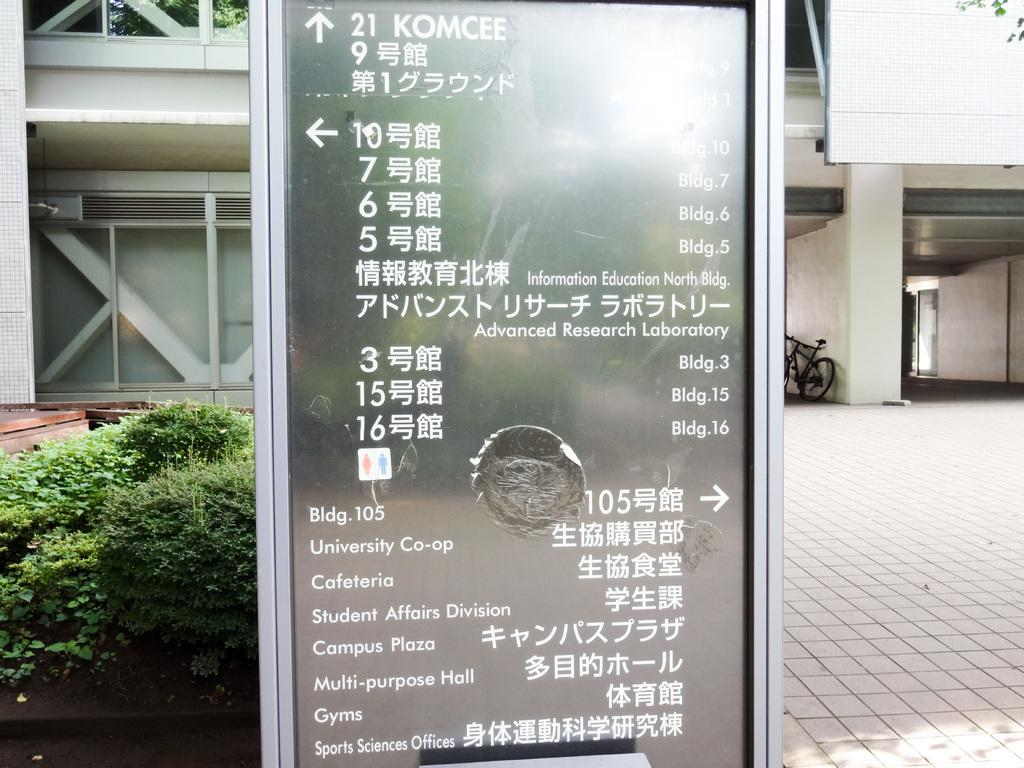What is the main object in the center of the image? There is a sign board in the center of the image. What information is displayed on the sign board? There is writing on the sign board. What can be seen in the background of the image? There is a building, a wall, a door, a cycle, and plants in the background of the image. Can you see a kitty playing with a quince in the image? No, there is no kitty or quince present in the image. Is there an airplane visible in the image? No, there is no airplane present in the image. 